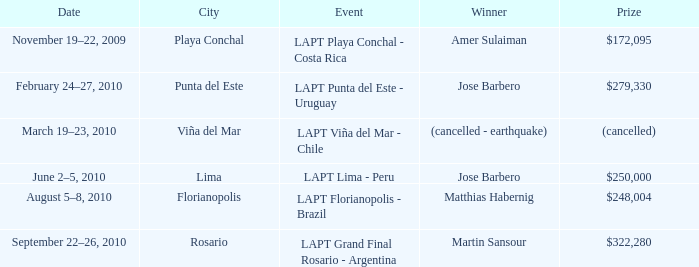What is the date of the event with a $322,280 prize? September 22–26, 2010. 